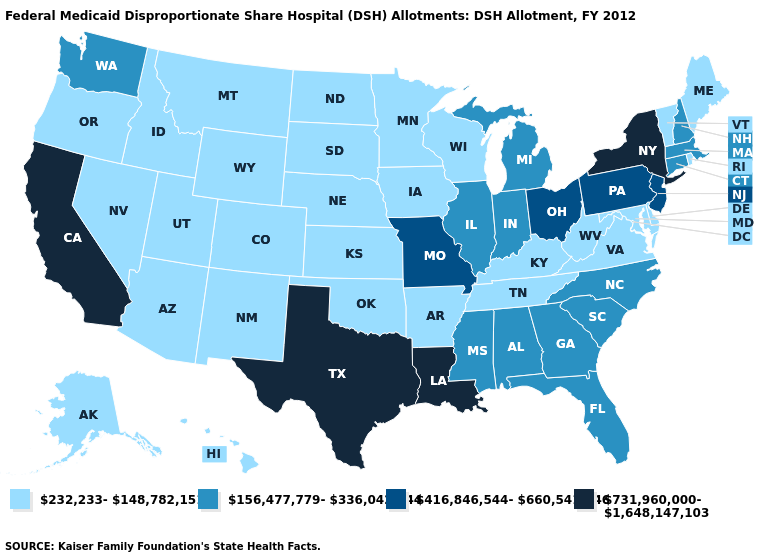Does Arkansas have the highest value in the South?
Short answer required. No. Does the map have missing data?
Quick response, please. No. Name the states that have a value in the range 731,960,000-1,648,147,103?
Answer briefly. California, Louisiana, New York, Texas. How many symbols are there in the legend?
Be succinct. 4. What is the value of Michigan?
Be succinct. 156,477,779-336,042,444. What is the highest value in states that border Idaho?
Keep it brief. 156,477,779-336,042,444. Name the states that have a value in the range 731,960,000-1,648,147,103?
Be succinct. California, Louisiana, New York, Texas. What is the value of Tennessee?
Concise answer only. 232,233-148,782,151. Among the states that border Virginia , does North Carolina have the lowest value?
Concise answer only. No. Name the states that have a value in the range 416,846,544-660,541,446?
Quick response, please. Missouri, New Jersey, Ohio, Pennsylvania. Name the states that have a value in the range 416,846,544-660,541,446?
Short answer required. Missouri, New Jersey, Ohio, Pennsylvania. Which states have the highest value in the USA?
Short answer required. California, Louisiana, New York, Texas. Among the states that border Kansas , does Missouri have the lowest value?
Be succinct. No. Name the states that have a value in the range 232,233-148,782,151?
Concise answer only. Alaska, Arizona, Arkansas, Colorado, Delaware, Hawaii, Idaho, Iowa, Kansas, Kentucky, Maine, Maryland, Minnesota, Montana, Nebraska, Nevada, New Mexico, North Dakota, Oklahoma, Oregon, Rhode Island, South Dakota, Tennessee, Utah, Vermont, Virginia, West Virginia, Wisconsin, Wyoming. Is the legend a continuous bar?
Quick response, please. No. 